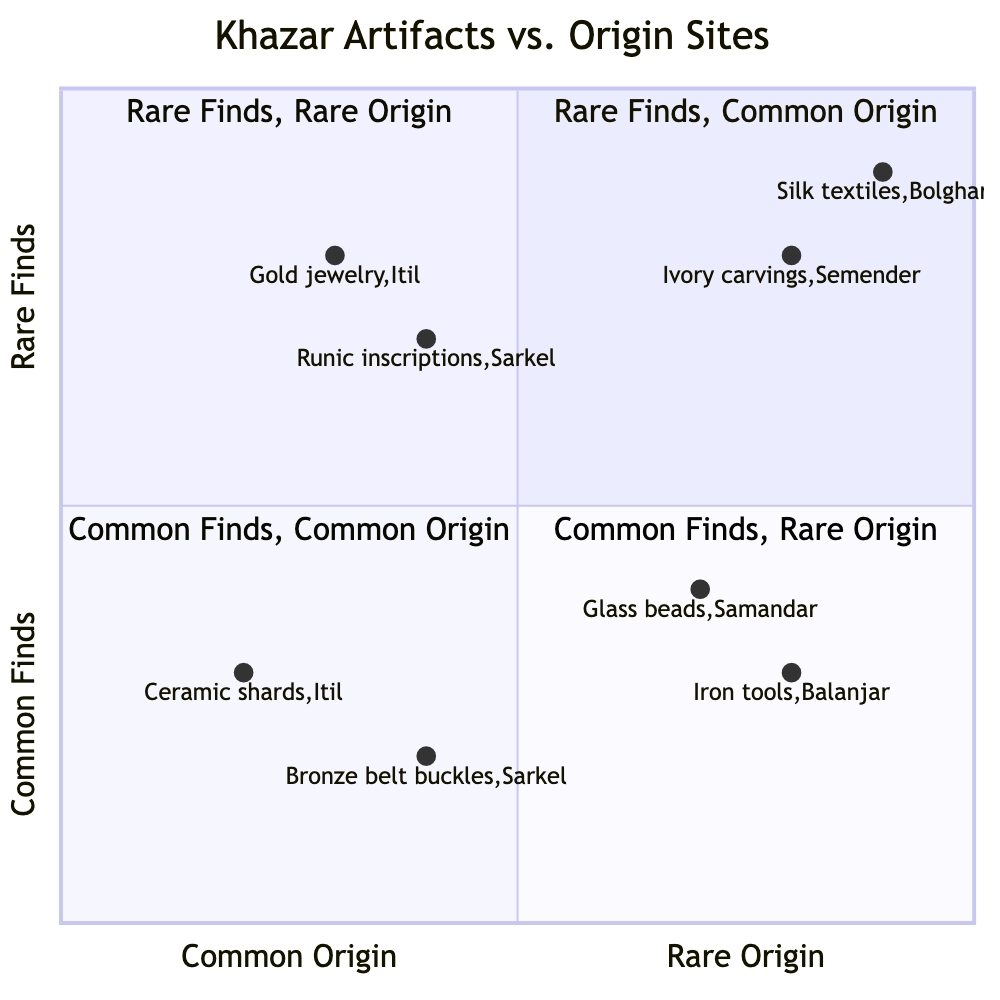What artifacts are found in the "Common Finds, Common Origin" quadrant? In the "Common Finds, Common Origin" quadrant, there are two artifacts listed: "Ceramic shards" from the origin site "Itil" and "Bronze belt buckles" from "Sarkel".
Answer: Ceramic shards, Bronze belt buckles Which artifact is associated with a rare origin? In the "Common Finds, Rare Origin" quadrant, the artifacts associated with a rare origin are "Glass beads" from "Samandar" and "Iron tools" from "Balanjar". The other quadrants contain artifacts that are either common or rare finds, but none from rare origin in this specific category of common finds.
Answer: Glass beads, Iron tools How many rare finds are from common origin sites? The "Rare Finds, Common Origin" quadrant contains two artifacts: "Gold jewelry" from "Itil" and "Runic inscriptions" from "Sarkel". Therefore, there are two rare finds from common origin sites.
Answer: 2 Which artifact in the "Rare Finds, Rare Origin" quadrant has an origin site in Bolghar? In the "Rare Finds, Rare Origin" quadrant, the artifact with an origin site in Bolghar is "Silk textiles".
Answer: Silk textiles What is the total number of artifacts categorized under "Common Finds"? In the diagram, there are two quadrants that contain common finds: "Common Finds, Common Origin" and "Common Finds, Rare Origin". The total number of artifacts in these quadrants is four: "Ceramic shards," "Bronze belt buckles," "Glass beads," and "Iron tools".
Answer: 4 Which is the only artifact listed in the "Rare Finds, Rare Origin" quadrant? The "Rare Finds, Rare Origin" quadrant contains two artifacts, "Silk textiles" from "Bolghar" and "Ivory carvings" from "Semender". There isn't just one artifact, so the answer is both listed.
Answer: Silk textiles, Ivory carvings Which artifact has an origin site that is not common? The "Common Finds, Rare Origin" quadrant includes artifacts like "Glass beads" from "Samandar" and "Iron tools" from "Balanjar", indicating that both have rare origins.
Answer: Glass beads, Iron tools How many artifacts are associated with the origin site Sarkel? In the diagram, Sarkel is associated with two artifacts: "Bronze belt buckles" in the "Common Finds, Common Origin" quadrant and "Runic inscriptions" in the "Rare Finds, Common Origin" quadrant. Thus, there are two artifacts from Sarkel.
Answer: 2 